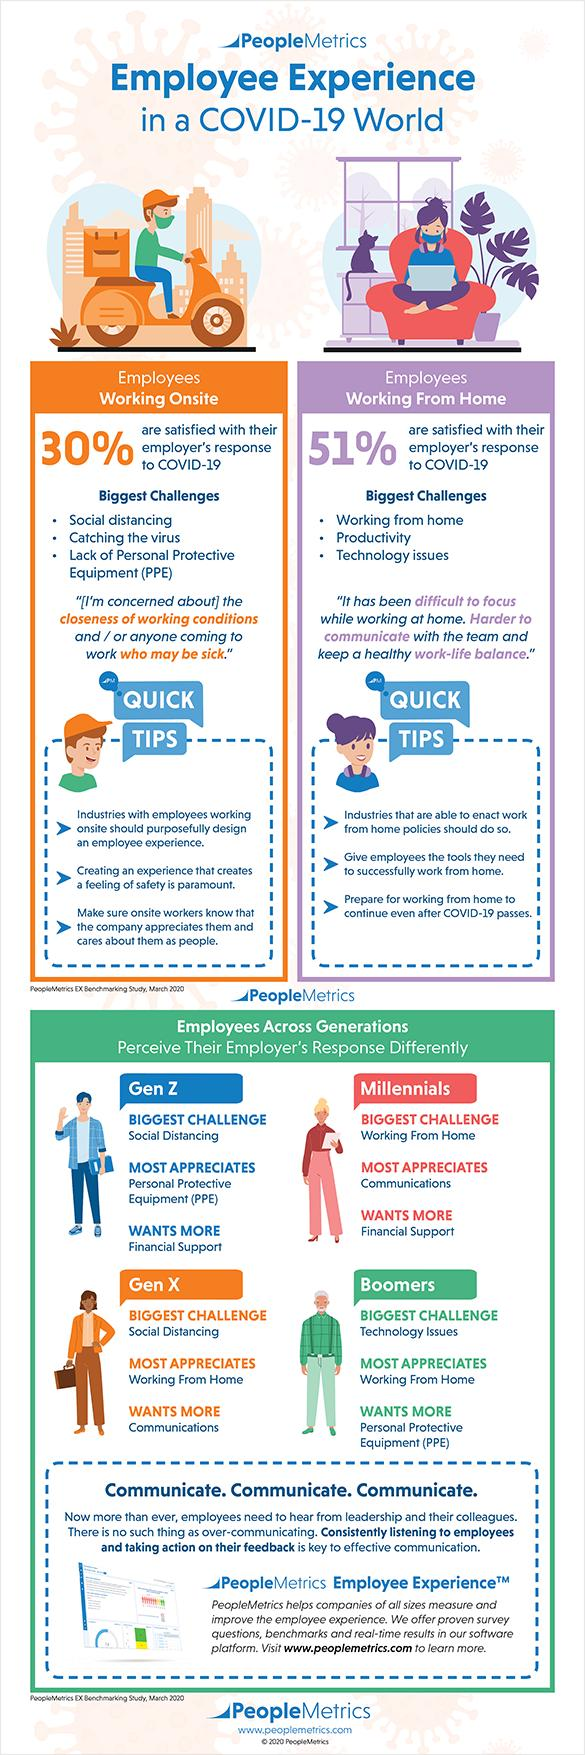Mention a couple of crucial points in this snapshot. A significant portion of employees who work from home and are dissatisfied with their employer's response to COVID-19 is 49%. Employees working from home face various challenges, with productivity being the most significant, as well as technology issues that can hinder their work. A study has shown that both Gen Z and Millennials are seeking more financial support from their parents and grandparents. It is my opinion that Generation X and the Baby Boomers are the generations that most appreciate working from home. Seventy percent of employees who work on-site are not satisfied with their employer's response to COVID-19, according to a recent survey. 